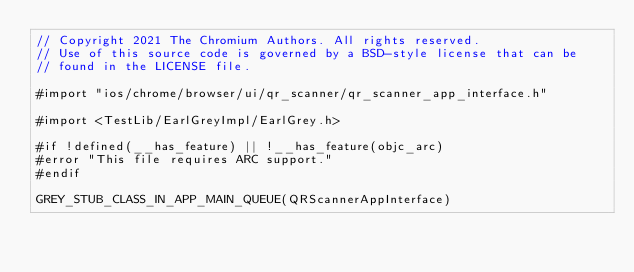Convert code to text. <code><loc_0><loc_0><loc_500><loc_500><_ObjectiveC_>// Copyright 2021 The Chromium Authors. All rights reserved.
// Use of this source code is governed by a BSD-style license that can be
// found in the LICENSE file.

#import "ios/chrome/browser/ui/qr_scanner/qr_scanner_app_interface.h"

#import <TestLib/EarlGreyImpl/EarlGrey.h>

#if !defined(__has_feature) || !__has_feature(objc_arc)
#error "This file requires ARC support."
#endif

GREY_STUB_CLASS_IN_APP_MAIN_QUEUE(QRScannerAppInterface)
</code> 